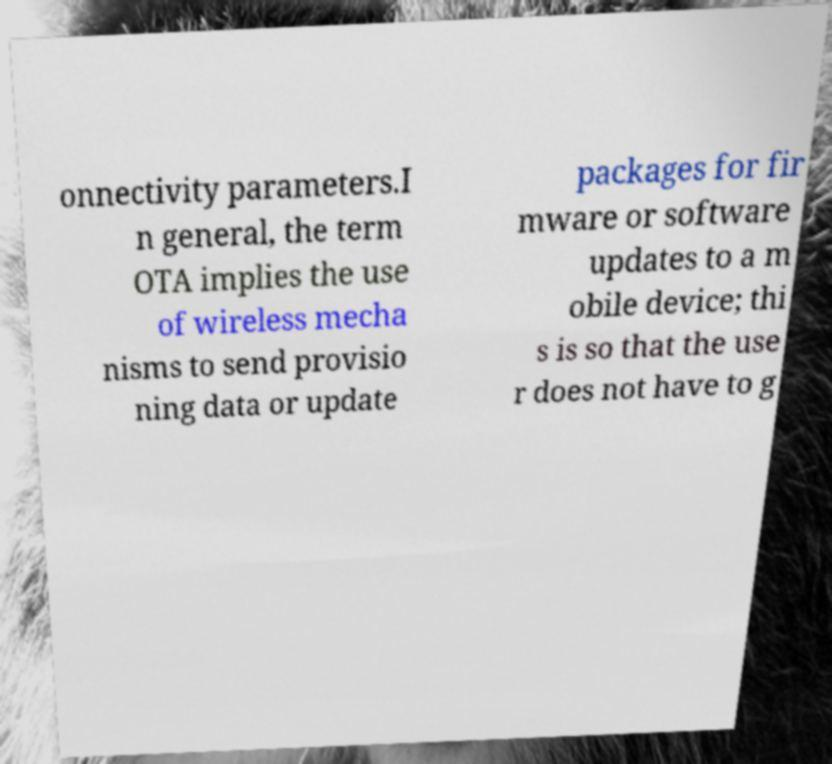Can you accurately transcribe the text from the provided image for me? onnectivity parameters.I n general, the term OTA implies the use of wireless mecha nisms to send provisio ning data or update packages for fir mware or software updates to a m obile device; thi s is so that the use r does not have to g 